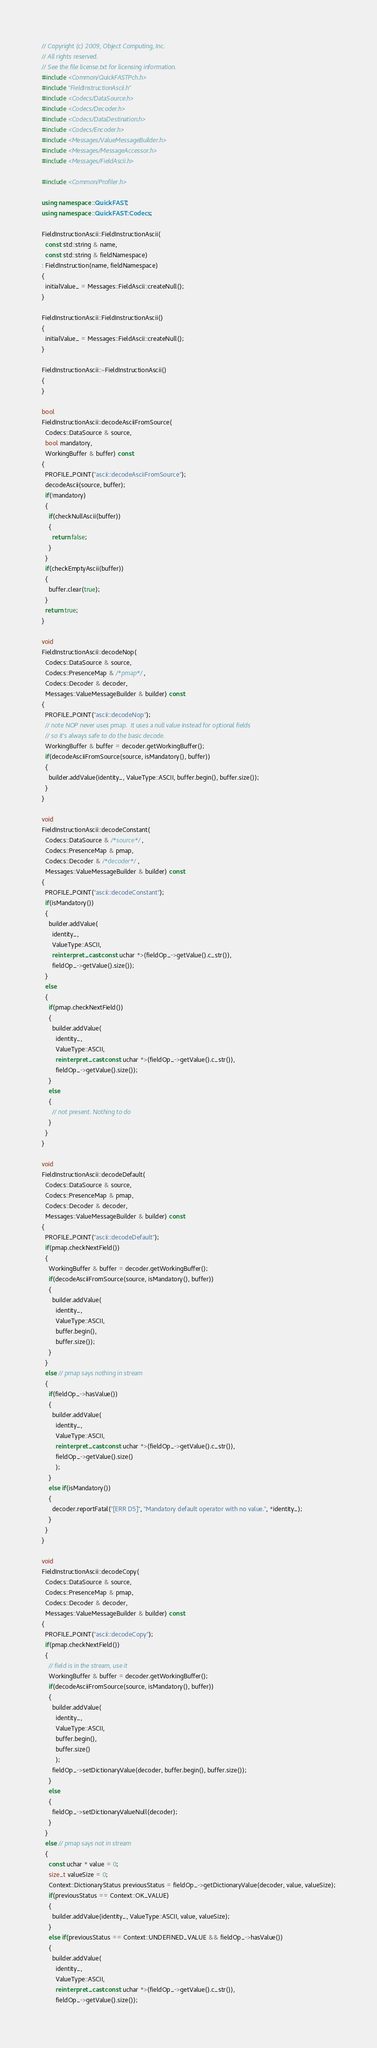<code> <loc_0><loc_0><loc_500><loc_500><_C++_>// Copyright (c) 2009, Object Computing, Inc.
// All rights reserved.
// See the file license.txt for licensing information.
#include <Common/QuickFASTPch.h>
#include "FieldInstructionAscii.h"
#include <Codecs/DataSource.h>
#include <Codecs/Decoder.h>
#include <Codecs/DataDestination.h>
#include <Codecs/Encoder.h>
#include <Messages/ValueMessageBuilder.h>
#include <Messages/MessageAccessor.h>
#include <Messages/FieldAscii.h>

#include <Common/Profiler.h>

using namespace ::QuickFAST;
using namespace ::QuickFAST::Codecs;

FieldInstructionAscii::FieldInstructionAscii(
  const std::string & name,
  const std::string & fieldNamespace)
: FieldInstruction(name, fieldNamespace)
{
  initialValue_ = Messages::FieldAscii::createNull();
}

FieldInstructionAscii::FieldInstructionAscii()
{
  initialValue_ = Messages::FieldAscii::createNull();
}

FieldInstructionAscii::~FieldInstructionAscii()
{
}

bool
FieldInstructionAscii::decodeAsciiFromSource(
  Codecs::DataSource & source,
  bool mandatory,
  WorkingBuffer & buffer) const
{
  PROFILE_POINT("ascii::decodeAsciiFromSource");
  decodeAscii(source, buffer);
  if(!mandatory)
  {
    if(checkNullAscii(buffer))
    {
      return false;
    }
  }
  if(checkEmptyAscii(buffer))
  {
    buffer.clear(true);
  }
  return true;
}

void
FieldInstructionAscii::decodeNop(
  Codecs::DataSource & source,
  Codecs::PresenceMap & /*pmap*/,
  Codecs::Decoder & decoder,
  Messages::ValueMessageBuilder & builder) const
{
  PROFILE_POINT("ascii::decodeNop");
  // note NOP never uses pmap.  It uses a null value instead for optional fields
  // so it's always safe to do the basic decode.
  WorkingBuffer & buffer = decoder.getWorkingBuffer();
  if(decodeAsciiFromSource(source, isMandatory(), buffer))
  {
    builder.addValue(identity_, ValueType::ASCII, buffer.begin(), buffer.size());
  }
}

void
FieldInstructionAscii::decodeConstant(
  Codecs::DataSource & /*source*/,
  Codecs::PresenceMap & pmap,
  Codecs::Decoder & /*decoder*/,
  Messages::ValueMessageBuilder & builder) const
{
  PROFILE_POINT("ascii::decodeConstant");
  if(isMandatory())
  {
    builder.addValue(
      identity_,
      ValueType::ASCII,
      reinterpret_cast<const uchar *>(fieldOp_->getValue().c_str()),
      fieldOp_->getValue().size());
  }
  else
  {
    if(pmap.checkNextField())
    {
      builder.addValue(
        identity_,
        ValueType::ASCII,
        reinterpret_cast<const uchar *>(fieldOp_->getValue().c_str()),
        fieldOp_->getValue().size());
    }
    else
    {
      // not present. Nothing to do
    }
  }
}

void
FieldInstructionAscii::decodeDefault(
  Codecs::DataSource & source,
  Codecs::PresenceMap & pmap,
  Codecs::Decoder & decoder,
  Messages::ValueMessageBuilder & builder) const
{
  PROFILE_POINT("ascii::decodeDefault");
  if(pmap.checkNextField())
  {
    WorkingBuffer & buffer = decoder.getWorkingBuffer();
    if(decodeAsciiFromSource(source, isMandatory(), buffer))
    {
      builder.addValue(
        identity_,
        ValueType::ASCII,
        buffer.begin(),
        buffer.size());
    }
  }
  else // pmap says nothing in stream
  {
    if(fieldOp_->hasValue())
    {
      builder.addValue(
        identity_,
        ValueType::ASCII,
        reinterpret_cast<const uchar *>(fieldOp_->getValue().c_str()),
        fieldOp_->getValue().size()
        );
    }
    else if(isMandatory())
    {
      decoder.reportFatal("[ERR D5]", "Mandatory default operator with no value.", *identity_);
    }
  }
}

void
FieldInstructionAscii::decodeCopy(
  Codecs::DataSource & source,
  Codecs::PresenceMap & pmap,
  Codecs::Decoder & decoder,
  Messages::ValueMessageBuilder & builder) const
{
  PROFILE_POINT("ascii::decodeCopy");
  if(pmap.checkNextField())
  {
    // field is in the stream, use it
    WorkingBuffer & buffer = decoder.getWorkingBuffer();
    if(decodeAsciiFromSource(source, isMandatory(), buffer))
    {
      builder.addValue(
        identity_,
        ValueType::ASCII,
        buffer.begin(),
        buffer.size()
        );
      fieldOp_->setDictionaryValue(decoder, buffer.begin(), buffer.size());
    }
    else
    {
      fieldOp_->setDictionaryValueNull(decoder);
    }
  }
  else // pmap says not in stream
  {
    const uchar * value = 0;
    size_t valueSize = 0;
    Context::DictionaryStatus previousStatus = fieldOp_->getDictionaryValue(decoder, value, valueSize);
    if(previousStatus == Context::OK_VALUE)
    {
      builder.addValue(identity_, ValueType::ASCII, value, valueSize);
    }
    else if(previousStatus == Context::UNDEFINED_VALUE && fieldOp_->hasValue())
    {
      builder.addValue(
        identity_,
        ValueType::ASCII,
        reinterpret_cast<const uchar *>(fieldOp_->getValue().c_str()),
        fieldOp_->getValue().size());</code> 